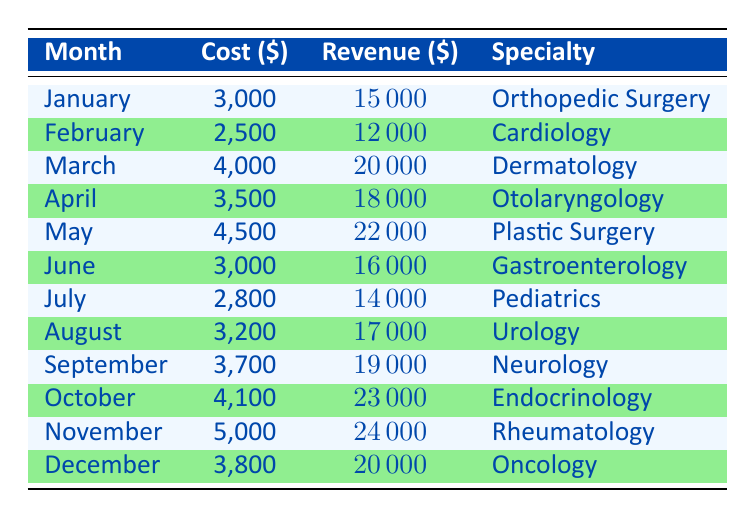What was the highest patient acquisition cost in the table? By inspecting the "Cost" column in the table, the highest patient acquisition cost listed is 5000, which occurs in November.
Answer: 5000 Which medical specialty generated the most revenue in a single month? Looking at the "Revenue" column, the highest revenue generated is 24000 in November, corresponding to the specialty of Rheumatology.
Answer: Rheumatology What is the average patient acquisition cost for the months listed? To calculate the average cost, sum all costs: (3000 + 2500 + 4000 + 3500 + 4500 + 3000 + 2800 + 3200 + 3700 + 4100 + 5000 + 3800) = 40100. Dividing this by 12 gives an average cost of 3341.67.
Answer: 3341.67 Did Dermatology have a higher revenue than Pediatrics in their respective months? Comparing the revenue values, Dermatology generated 20000 in March, while Pediatrics generated 14000 in July. Since 20000 is greater than 14000, the statement is true.
Answer: Yes What was the total revenue generated from March to May? The revenue for March is 20000, for April it's 18000, and for May it's 22000. Adding these together: 20000 + 18000 + 22000 = 60000.
Answer: 60000 Was the cost in February lower than the cost in September? The cost for February is 2500 and for September is 3700. Since 2500 is less than 3700, the statement is true.
Answer: Yes What is the difference in revenue generated between Oncology and Orthopedic Surgery? The revenue for Oncology is 20000, and for Orthopedic Surgery, it is 15000. The difference is calculated as: 20000 - 15000 = 5000.
Answer: 5000 Which month had a cost of 3200, and what was the corresponding revenue? Looking for the month with a cost of 3200, it is found in August. The corresponding revenue for August is 17000.
Answer: August, 17000 What is the total patient acquisition cost for the last quarter (October to December)? The costs for October, November, and December are 4100, 5000, and 3800 respectively. Summing these gives: 4100 + 5000 + 3800 = 12900.
Answer: 12900 